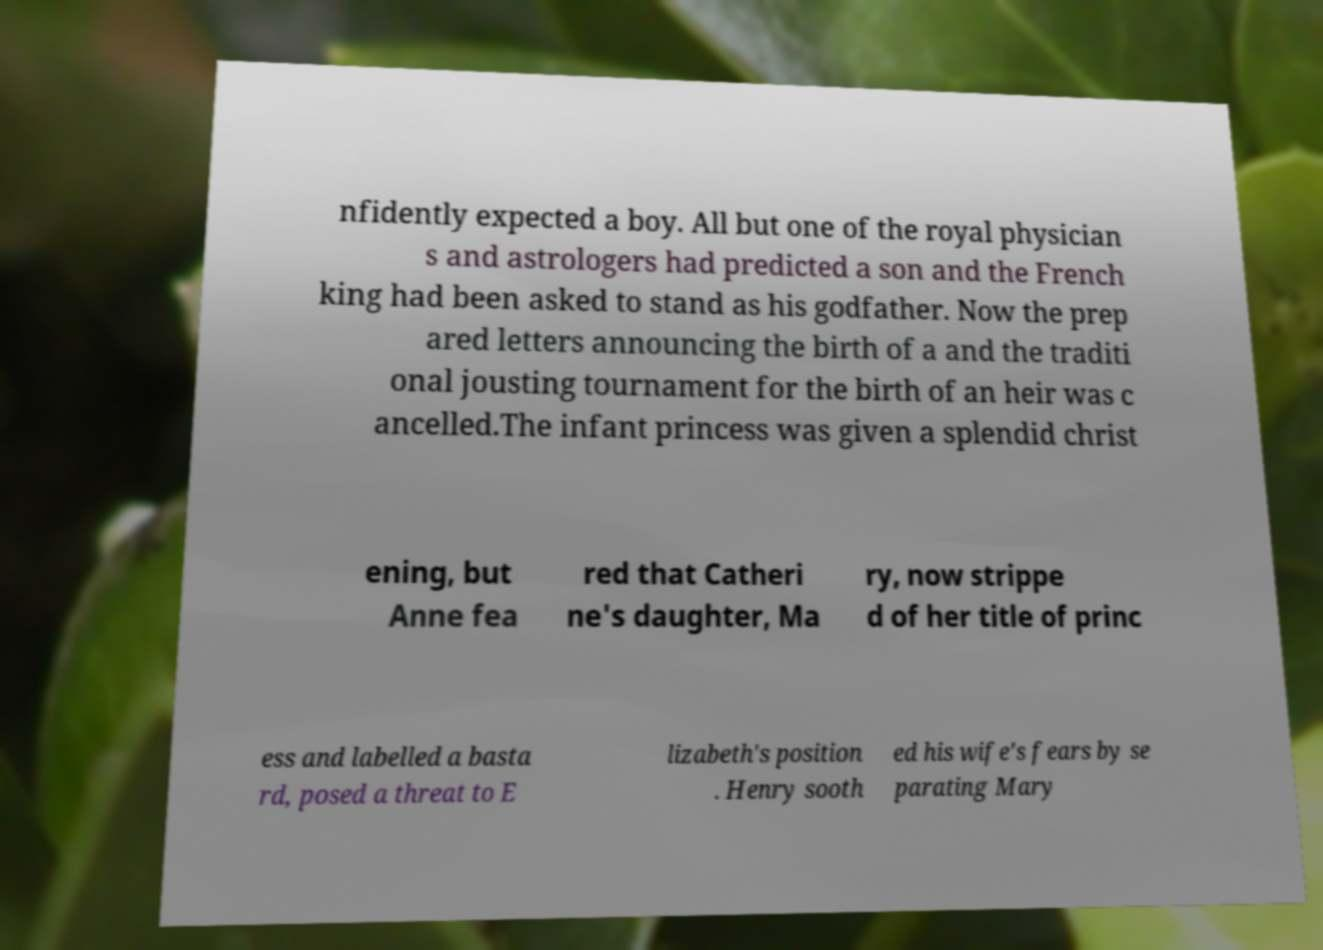Could you assist in decoding the text presented in this image and type it out clearly? nfidently expected a boy. All but one of the royal physician s and astrologers had predicted a son and the French king had been asked to stand as his godfather. Now the prep ared letters announcing the birth of a and the traditi onal jousting tournament for the birth of an heir was c ancelled.The infant princess was given a splendid christ ening, but Anne fea red that Catheri ne's daughter, Ma ry, now strippe d of her title of princ ess and labelled a basta rd, posed a threat to E lizabeth's position . Henry sooth ed his wife's fears by se parating Mary 